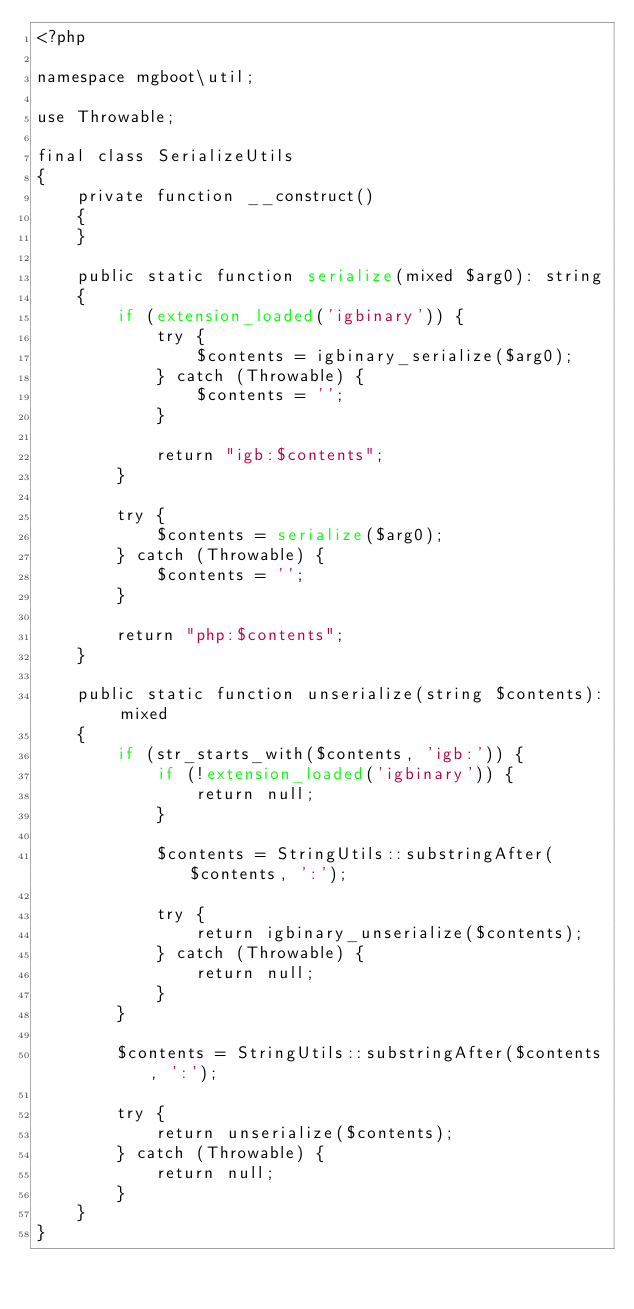<code> <loc_0><loc_0><loc_500><loc_500><_PHP_><?php

namespace mgboot\util;

use Throwable;

final class SerializeUtils
{
    private function __construct()
    {
    }

    public static function serialize(mixed $arg0): string
    {
        if (extension_loaded('igbinary')) {
            try {
                $contents = igbinary_serialize($arg0);
            } catch (Throwable) {
                $contents = '';
            }

            return "igb:$contents";
        }

        try {
            $contents = serialize($arg0);
        } catch (Throwable) {
            $contents = '';
        }

        return "php:$contents";
    }

    public static function unserialize(string $contents): mixed
    {
        if (str_starts_with($contents, 'igb:')) {
            if (!extension_loaded('igbinary')) {
                return null;
            }

            $contents = StringUtils::substringAfter($contents, ':');

            try {
                return igbinary_unserialize($contents);
            } catch (Throwable) {
                return null;
            }
        }

        $contents = StringUtils::substringAfter($contents, ':');

        try {
            return unserialize($contents);
        } catch (Throwable) {
            return null;
        }
    }
}
</code> 